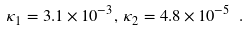Convert formula to latex. <formula><loc_0><loc_0><loc_500><loc_500>\kappa _ { 1 } = 3 . 1 \times 1 0 ^ { - 3 } , \, \kappa _ { 2 } = 4 . 8 \times 1 0 ^ { - 5 } \ .</formula> 